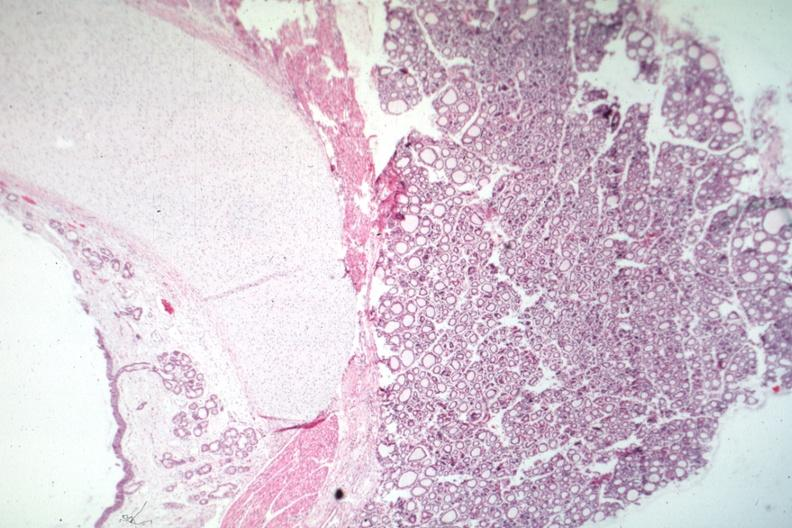s angiogram present?
Answer the question using a single word or phrase. No 